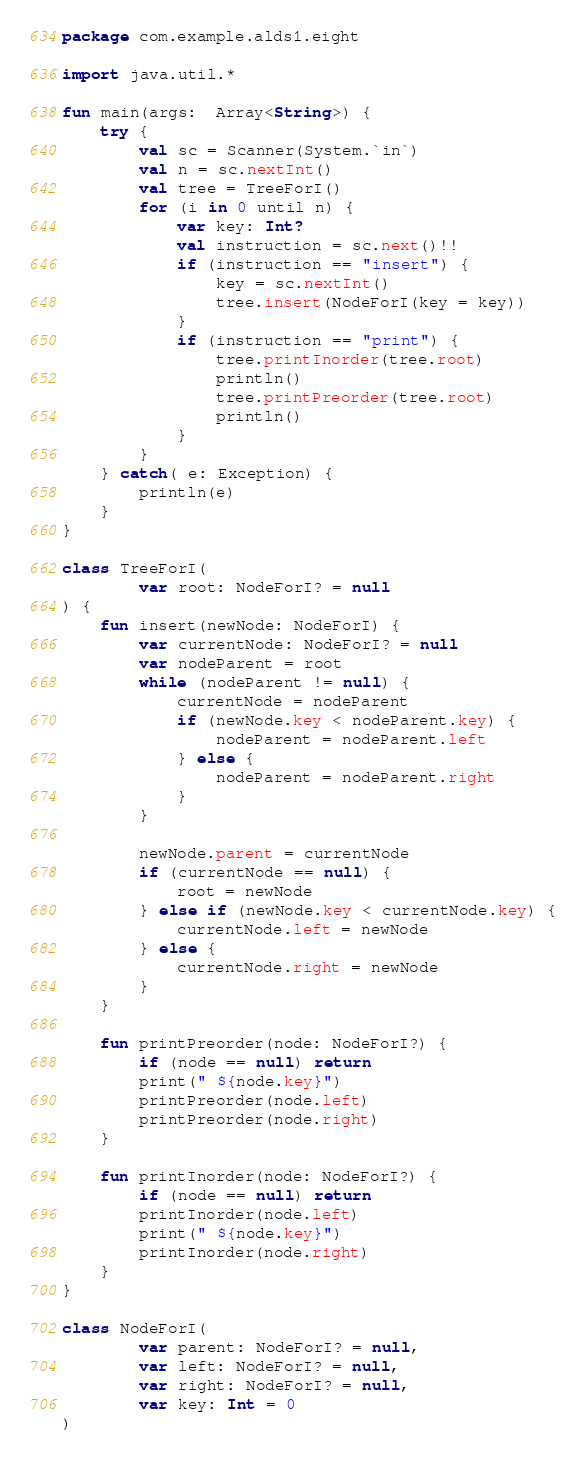<code> <loc_0><loc_0><loc_500><loc_500><_Kotlin_>package com.example.alds1.eight

import java.util.*

fun main(args:  Array<String>) {
    try {
        val sc = Scanner(System.`in`)
        val n = sc.nextInt()
        val tree = TreeForI()
        for (i in 0 until n) {
            var key: Int?
            val instruction = sc.next()!!
            if (instruction == "insert") {
                key = sc.nextInt()
                tree.insert(NodeForI(key = key))
            }
            if (instruction == "print") {
                tree.printInorder(tree.root)
                println()
                tree.printPreorder(tree.root)
                println()
            }
        }
    } catch( e: Exception) {
        println(e)
    }
}

class TreeForI(
        var root: NodeForI? = null
) {
    fun insert(newNode: NodeForI) {
        var currentNode: NodeForI? = null
        var nodeParent = root
        while (nodeParent != null) {
            currentNode = nodeParent
            if (newNode.key < nodeParent.key) {
                nodeParent = nodeParent.left
            } else {
                nodeParent = nodeParent.right
            }
        }

        newNode.parent = currentNode
        if (currentNode == null) {
            root = newNode
        } else if (newNode.key < currentNode.key) {
            currentNode.left = newNode
        } else {
            currentNode.right = newNode
        }
    }

    fun printPreorder(node: NodeForI?) {
        if (node == null) return
        print(" ${node.key}")
        printPreorder(node.left)
        printPreorder(node.right)
    }

    fun printInorder(node: NodeForI?) {
        if (node == null) return
        printInorder(node.left)
        print(" ${node.key}")
        printInorder(node.right)
    }
}

class NodeForI(
        var parent: NodeForI? = null,
        var left: NodeForI? = null,
        var right: NodeForI? = null,
        var key: Int = 0
)


</code> 